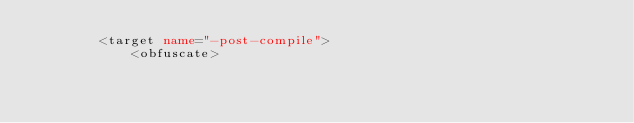<code> <loc_0><loc_0><loc_500><loc_500><_XML_>        <target name="-post-compile">
            <obfuscate></code> 